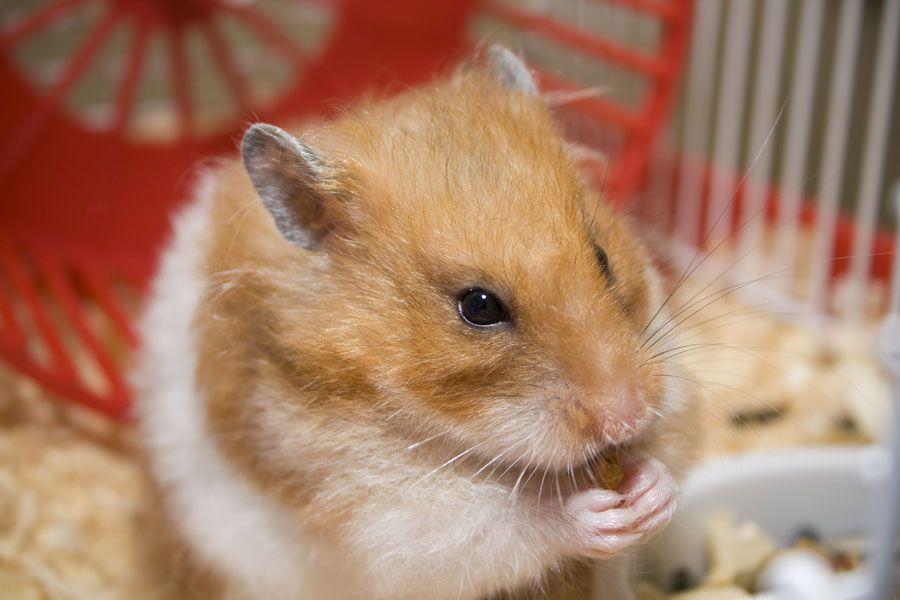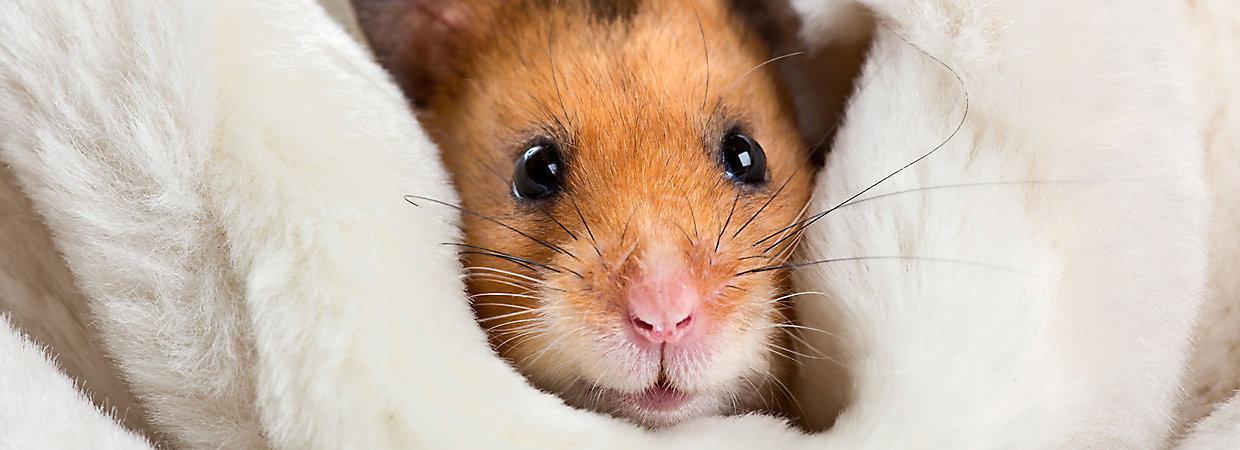The first image is the image on the left, the second image is the image on the right. For the images shown, is this caption "There is a hamster eating a carrot." true? Answer yes or no. No. 